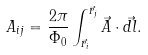<formula> <loc_0><loc_0><loc_500><loc_500>A _ { i j } = \frac { 2 \pi } { \Phi _ { 0 } } \int _ { \vec { r } _ { i } } ^ { \vec { r } _ { j } } \vec { A } \cdot \vec { d l } .</formula> 